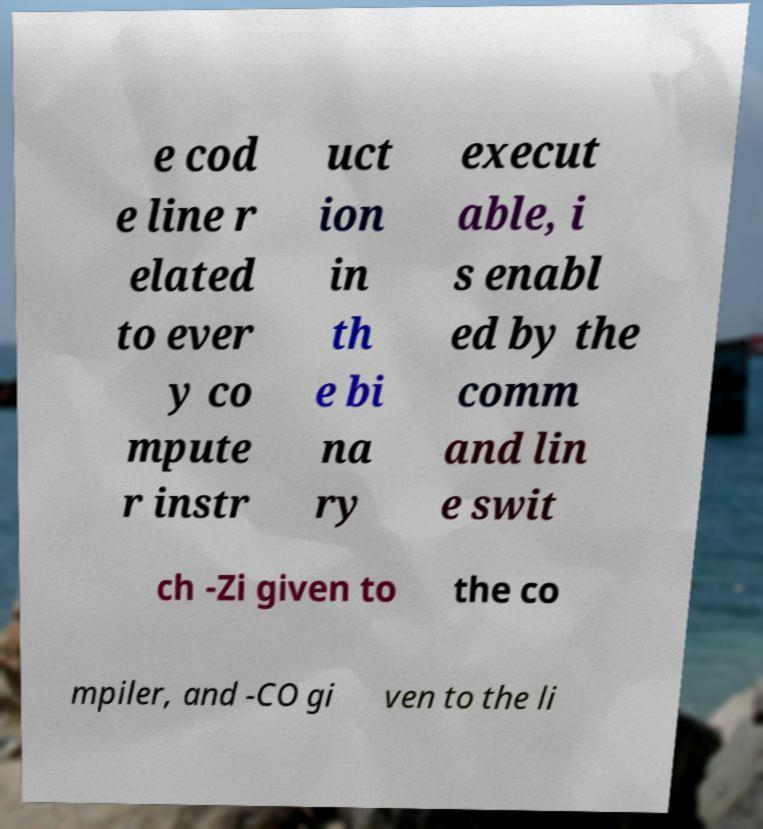Can you read and provide the text displayed in the image?This photo seems to have some interesting text. Can you extract and type it out for me? e cod e line r elated to ever y co mpute r instr uct ion in th e bi na ry execut able, i s enabl ed by the comm and lin e swit ch -Zi given to the co mpiler, and -CO gi ven to the li 